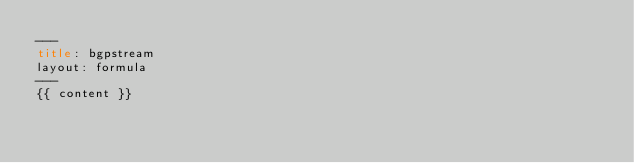Convert code to text. <code><loc_0><loc_0><loc_500><loc_500><_HTML_>---
title: bgpstream
layout: formula
---
{{ content }}
</code> 